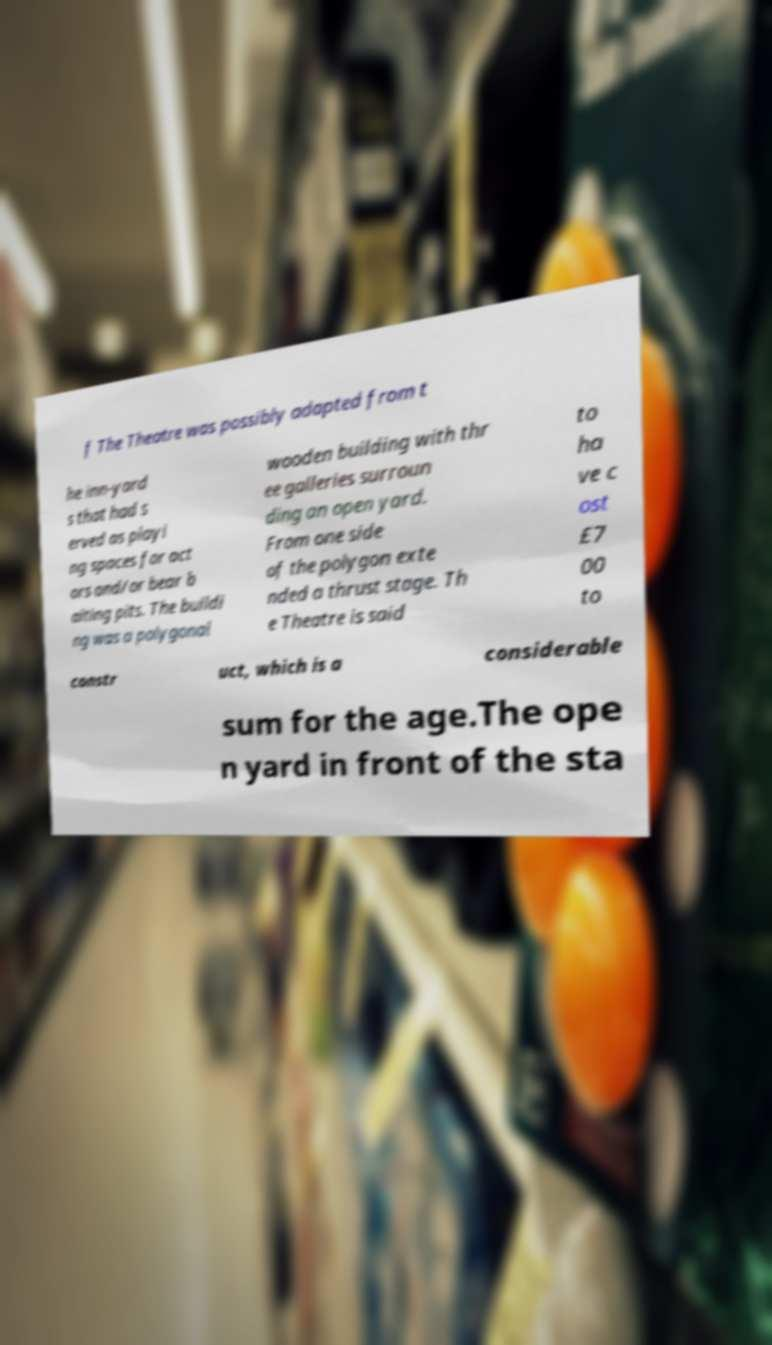I need the written content from this picture converted into text. Can you do that? f The Theatre was possibly adapted from t he inn-yard s that had s erved as playi ng spaces for act ors and/or bear b aiting pits. The buildi ng was a polygonal wooden building with thr ee galleries surroun ding an open yard. From one side of the polygon exte nded a thrust stage. Th e Theatre is said to ha ve c ost £7 00 to constr uct, which is a considerable sum for the age.The ope n yard in front of the sta 